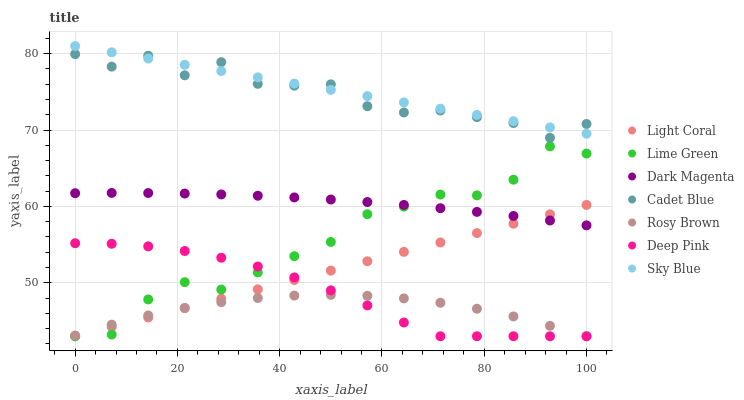Does Rosy Brown have the minimum area under the curve?
Answer yes or no. Yes. Does Sky Blue have the maximum area under the curve?
Answer yes or no. Yes. Does Dark Magenta have the minimum area under the curve?
Answer yes or no. No. Does Dark Magenta have the maximum area under the curve?
Answer yes or no. No. Is Light Coral the smoothest?
Answer yes or no. Yes. Is Cadet Blue the roughest?
Answer yes or no. Yes. Is Dark Magenta the smoothest?
Answer yes or no. No. Is Dark Magenta the roughest?
Answer yes or no. No. Does Rosy Brown have the lowest value?
Answer yes or no. Yes. Does Dark Magenta have the lowest value?
Answer yes or no. No. Does Sky Blue have the highest value?
Answer yes or no. Yes. Does Dark Magenta have the highest value?
Answer yes or no. No. Is Light Coral less than Cadet Blue?
Answer yes or no. Yes. Is Cadet Blue greater than Dark Magenta?
Answer yes or no. Yes. Does Dark Magenta intersect Light Coral?
Answer yes or no. Yes. Is Dark Magenta less than Light Coral?
Answer yes or no. No. Is Dark Magenta greater than Light Coral?
Answer yes or no. No. Does Light Coral intersect Cadet Blue?
Answer yes or no. No. 